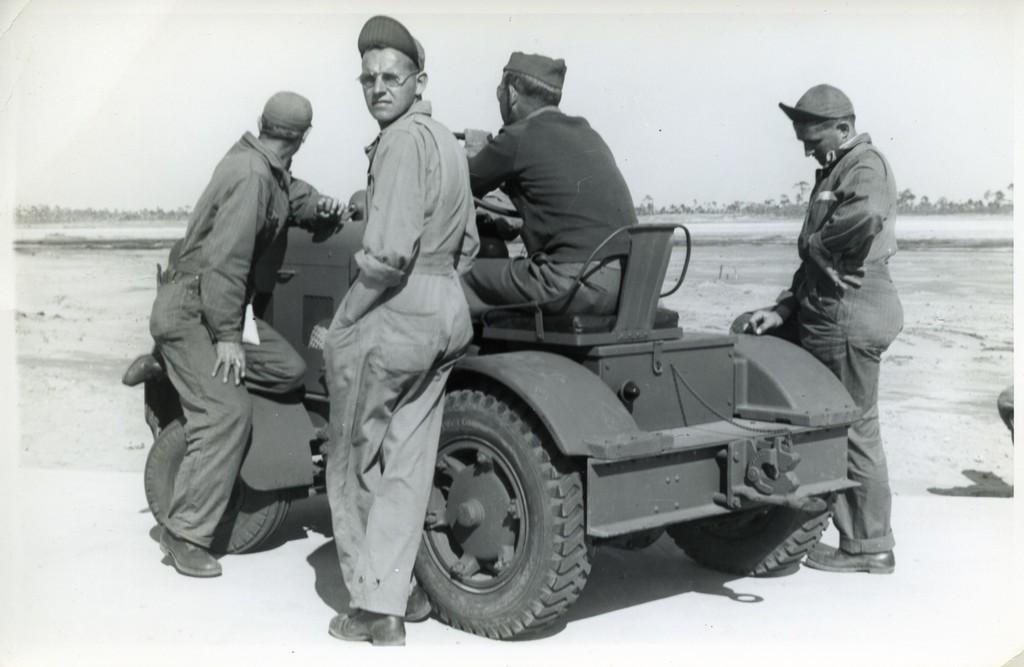Can you describe this image briefly? In this picture there is a man wearing a brown color dress standing and giving a pose into the camera. Behind there is a man sitting on the jeep and beside a another man who is standing near the wheel of the jeep. In the background there are some small trees. 